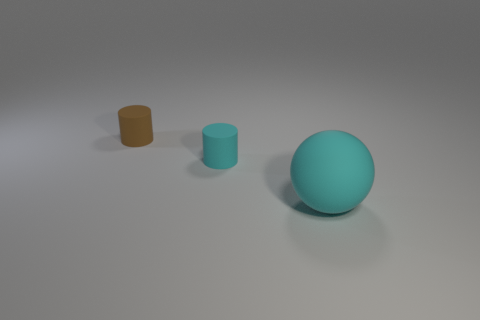Subtract all cylinders. How many objects are left? 1 Subtract 1 cylinders. How many cylinders are left? 1 Subtract all red cylinders. Subtract all purple balls. How many cylinders are left? 2 Subtract all blue cylinders. How many blue balls are left? 0 Subtract all big shiny things. Subtract all cyan things. How many objects are left? 1 Add 1 matte cylinders. How many matte cylinders are left? 3 Add 3 rubber objects. How many rubber objects exist? 6 Add 2 big cyan spheres. How many objects exist? 5 Subtract all brown cylinders. How many cylinders are left? 1 Subtract 0 purple cylinders. How many objects are left? 3 